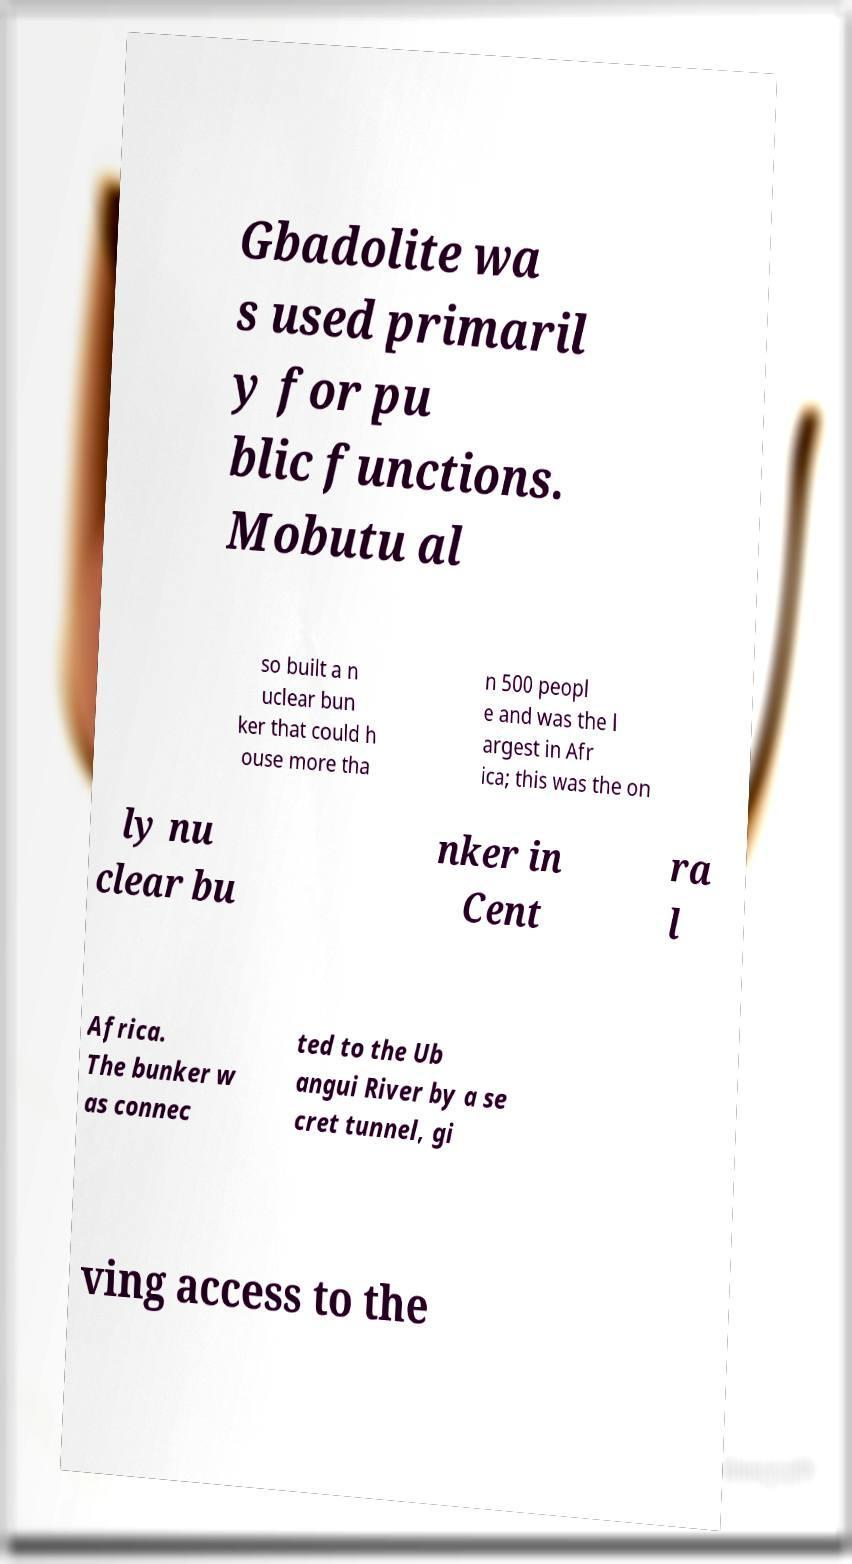Please identify and transcribe the text found in this image. Gbadolite wa s used primaril y for pu blic functions. Mobutu al so built a n uclear bun ker that could h ouse more tha n 500 peopl e and was the l argest in Afr ica; this was the on ly nu clear bu nker in Cent ra l Africa. The bunker w as connec ted to the Ub angui River by a se cret tunnel, gi ving access to the 